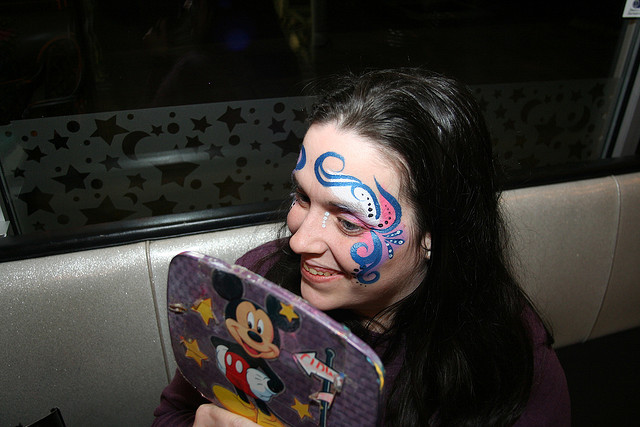Please transcribe the text information in this image. TIDW 